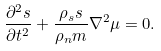<formula> <loc_0><loc_0><loc_500><loc_500>\frac { \partial ^ { 2 } s } { \partial t ^ { 2 } } + \frac { \rho _ { s } s } { \rho _ { n } m } \nabla ^ { 2 } \mu = 0 .</formula> 